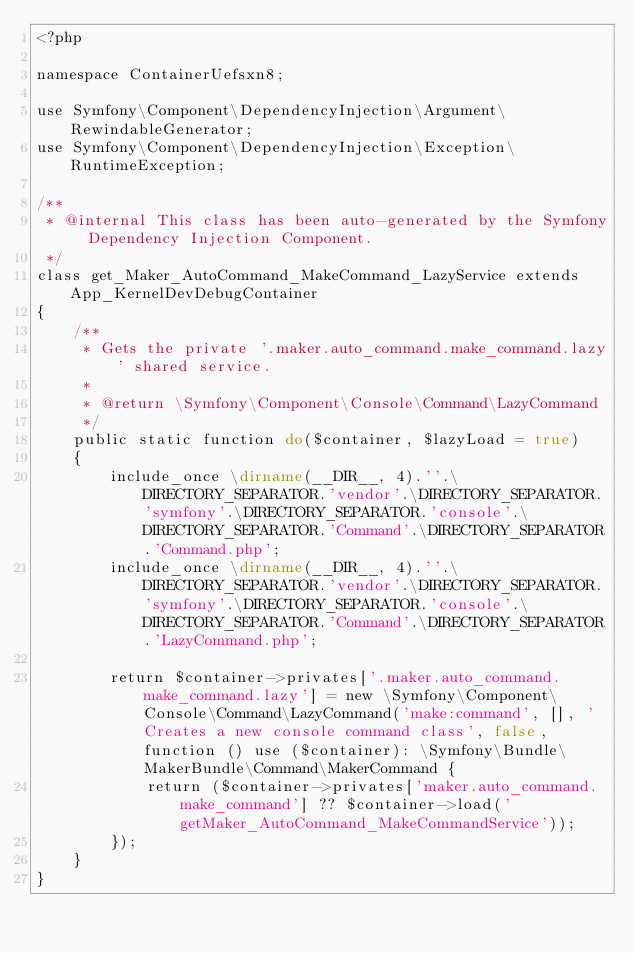<code> <loc_0><loc_0><loc_500><loc_500><_PHP_><?php

namespace ContainerUefsxn8;

use Symfony\Component\DependencyInjection\Argument\RewindableGenerator;
use Symfony\Component\DependencyInjection\Exception\RuntimeException;

/**
 * @internal This class has been auto-generated by the Symfony Dependency Injection Component.
 */
class get_Maker_AutoCommand_MakeCommand_LazyService extends App_KernelDevDebugContainer
{
    /**
     * Gets the private '.maker.auto_command.make_command.lazy' shared service.
     *
     * @return \Symfony\Component\Console\Command\LazyCommand
     */
    public static function do($container, $lazyLoad = true)
    {
        include_once \dirname(__DIR__, 4).''.\DIRECTORY_SEPARATOR.'vendor'.\DIRECTORY_SEPARATOR.'symfony'.\DIRECTORY_SEPARATOR.'console'.\DIRECTORY_SEPARATOR.'Command'.\DIRECTORY_SEPARATOR.'Command.php';
        include_once \dirname(__DIR__, 4).''.\DIRECTORY_SEPARATOR.'vendor'.\DIRECTORY_SEPARATOR.'symfony'.\DIRECTORY_SEPARATOR.'console'.\DIRECTORY_SEPARATOR.'Command'.\DIRECTORY_SEPARATOR.'LazyCommand.php';

        return $container->privates['.maker.auto_command.make_command.lazy'] = new \Symfony\Component\Console\Command\LazyCommand('make:command', [], 'Creates a new console command class', false, function () use ($container): \Symfony\Bundle\MakerBundle\Command\MakerCommand {
            return ($container->privates['maker.auto_command.make_command'] ?? $container->load('getMaker_AutoCommand_MakeCommandService'));
        });
    }
}
</code> 